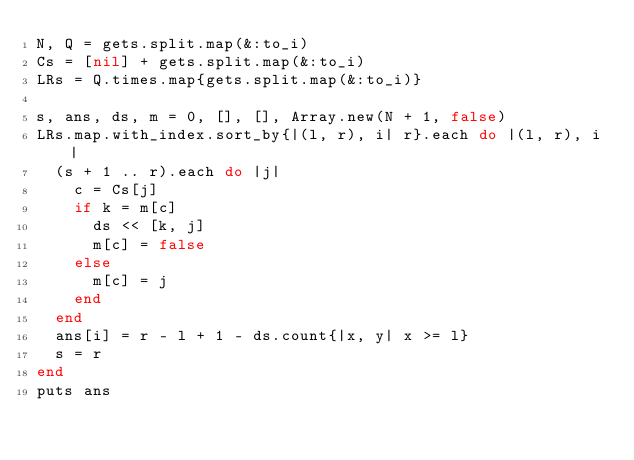Convert code to text. <code><loc_0><loc_0><loc_500><loc_500><_Ruby_>N, Q = gets.split.map(&:to_i)
Cs = [nil] + gets.split.map(&:to_i)
LRs = Q.times.map{gets.split.map(&:to_i)}

s, ans, ds, m = 0, [], [], Array.new(N + 1, false)
LRs.map.with_index.sort_by{|(l, r), i| r}.each do |(l, r), i|
  (s + 1 .. r).each do |j|
    c = Cs[j]
    if k = m[c]
      ds << [k, j]
      m[c] = false
    else
      m[c] = j
    end
  end
  ans[i] = r - l + 1 - ds.count{|x, y| x >= l}
  s = r
end
puts ans</code> 